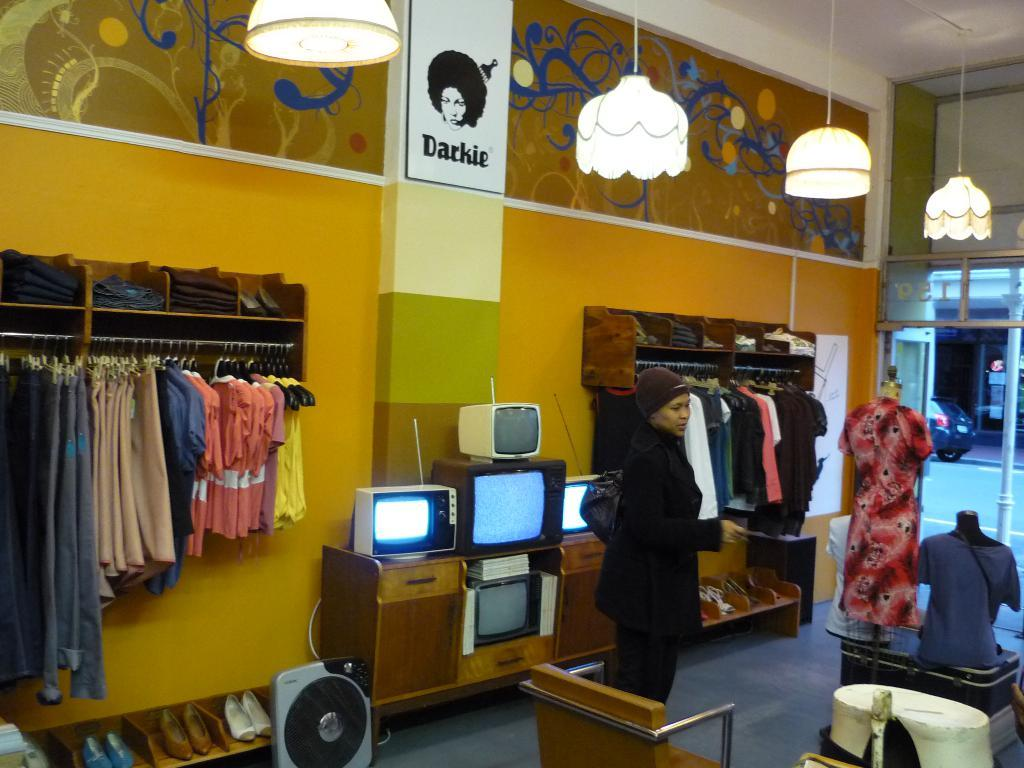What type of clothing items are hanging in the image? There are dresses on hangers in the image. What other objects can be seen among the dresses? There are televisions among the dresses. Can you describe the person's position in the image? A person is standing in front of a television. What type of trade is being conducted in the image? There is no indication of any trade being conducted in the image. What loss is being experienced by the person in the image? There is no indication of any loss being experienced by the person in the image. 